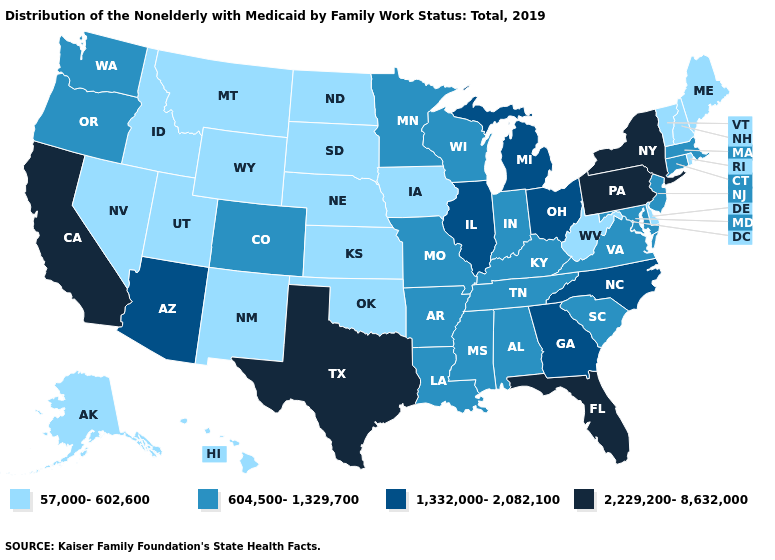What is the value of Wisconsin?
Quick response, please. 604,500-1,329,700. What is the highest value in the Northeast ?
Quick response, please. 2,229,200-8,632,000. Name the states that have a value in the range 57,000-602,600?
Short answer required. Alaska, Delaware, Hawaii, Idaho, Iowa, Kansas, Maine, Montana, Nebraska, Nevada, New Hampshire, New Mexico, North Dakota, Oklahoma, Rhode Island, South Dakota, Utah, Vermont, West Virginia, Wyoming. Name the states that have a value in the range 604,500-1,329,700?
Short answer required. Alabama, Arkansas, Colorado, Connecticut, Indiana, Kentucky, Louisiana, Maryland, Massachusetts, Minnesota, Mississippi, Missouri, New Jersey, Oregon, South Carolina, Tennessee, Virginia, Washington, Wisconsin. What is the value of Missouri?
Give a very brief answer. 604,500-1,329,700. Which states have the highest value in the USA?
Keep it brief. California, Florida, New York, Pennsylvania, Texas. Does New Jersey have a higher value than Hawaii?
Concise answer only. Yes. Name the states that have a value in the range 57,000-602,600?
Answer briefly. Alaska, Delaware, Hawaii, Idaho, Iowa, Kansas, Maine, Montana, Nebraska, Nevada, New Hampshire, New Mexico, North Dakota, Oklahoma, Rhode Island, South Dakota, Utah, Vermont, West Virginia, Wyoming. Name the states that have a value in the range 2,229,200-8,632,000?
Keep it brief. California, Florida, New York, Pennsylvania, Texas. What is the value of California?
Keep it brief. 2,229,200-8,632,000. Among the states that border Wyoming , does Colorado have the highest value?
Concise answer only. Yes. What is the highest value in the West ?
Be succinct. 2,229,200-8,632,000. What is the lowest value in the South?
Give a very brief answer. 57,000-602,600. Does Wyoming have the lowest value in the USA?
Concise answer only. Yes. What is the lowest value in states that border California?
Quick response, please. 57,000-602,600. 